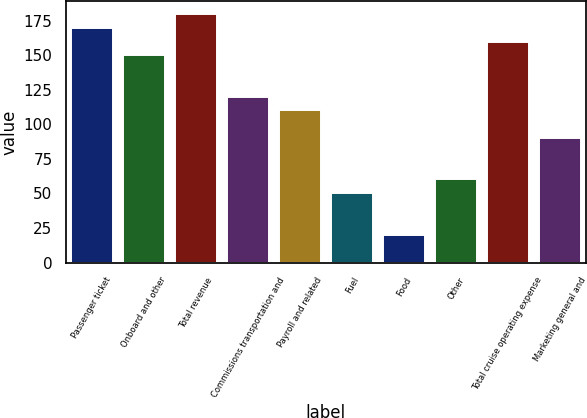<chart> <loc_0><loc_0><loc_500><loc_500><bar_chart><fcel>Passenger ticket<fcel>Onboard and other<fcel>Total revenue<fcel>Commissions transportation and<fcel>Payroll and related<fcel>Fuel<fcel>Food<fcel>Other<fcel>Total cruise operating expense<fcel>Marketing general and<nl><fcel>169.86<fcel>149.9<fcel>179.84<fcel>119.96<fcel>109.98<fcel>50.1<fcel>20.16<fcel>60.08<fcel>159.88<fcel>90.02<nl></chart> 